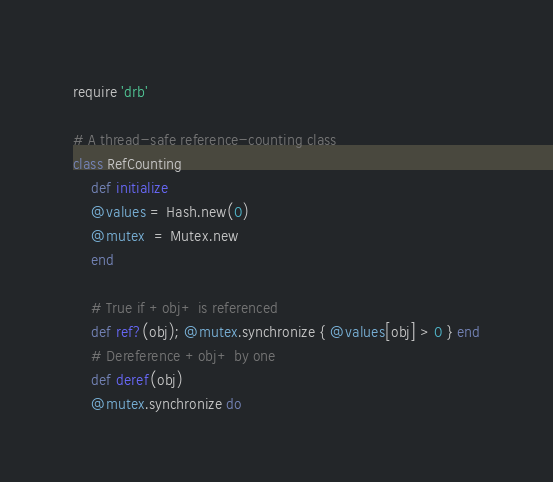Convert code to text. <code><loc_0><loc_0><loc_500><loc_500><_Ruby_>require 'drb'

# A thread-safe reference-counting class
class RefCounting
    def initialize
	@values = Hash.new(0)
	@mutex  = Mutex.new
    end

    # True if +obj+ is referenced
    def ref?(obj); @mutex.synchronize { @values[obj] > 0 } end
    # Dereference +obj+ by one
    def deref(obj)
	@mutex.synchronize do</code> 